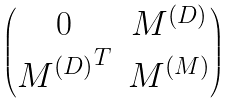<formula> <loc_0><loc_0><loc_500><loc_500>\begin{pmatrix} 0 & M ^ { ( D ) } \\ { M ^ { ( D ) } } ^ { T } & M ^ { ( M ) } \end{pmatrix}</formula> 